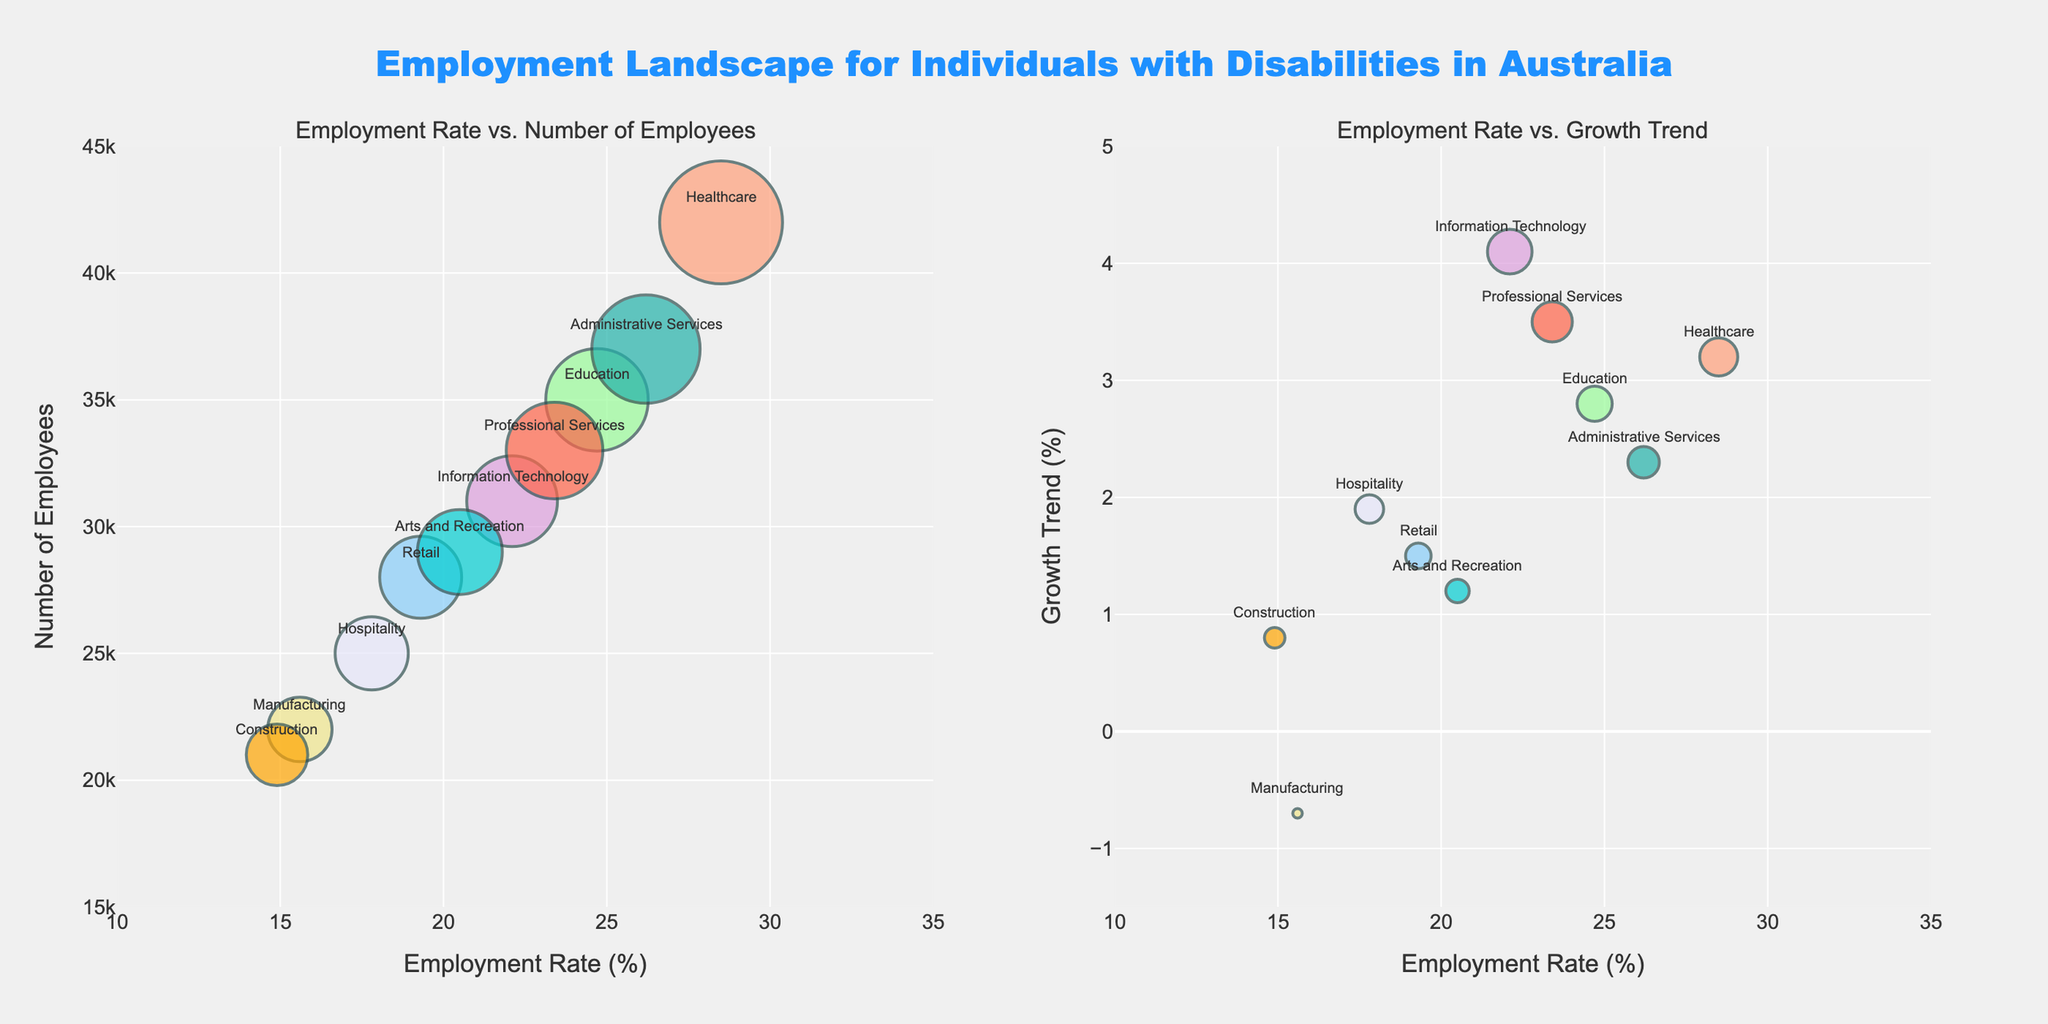What is the total number of employees in the Education and Healthcare industries combined? Looking at the figure, the number of employees in Education is 35,000 and in Healthcare is 42,000. Adding these together gives 35,000 + 42,000 = 77,000.
Answer: 77,000 Which industry has the highest employment rate? By observing the Employment Rate axis and the bubble positions, Healthcare has the highest employment rate at 28.5%.
Answer: Healthcare How does the growth trend of the Information Technology industry compare to that of Manufacturing? The Information Technology industry has a growth trend of 4.1%, while Manufacturing has a growth trend of -0.7%. Therefore, Information Technology is growing faster or Manufacturing is shrinking while IT is growing.
Answer: Information Technology is growing faster What is the employment rate for the industry with the smallest number of employees? The industry with the smallest number of employees is Construction with 21,000. The employment rate for Construction is 14.9%.
Answer: 14.9% Which industry appears to have the largest bubble in the "Employment Rate vs. Number of Employees" plot? In the first plot, the size of the bubbles corresponds to the number of employees. The largest bubble represents Healthcare, which has the highest number of employees at 42,000.
Answer: Healthcare Compare the employment rates of the Healthcare and Administrative Services industries. Healthcare has an employment rate of 28.5%, while Administrative Services has an employment rate of 26.2%. Therefore, Healthcare's rate is higher by 2.3 percentage points.
Answer: Healthcare's is higher Which industries show a negative growth trend? By looking at the Growth Trend axis and the bubble positions, Manufacturing shows a negative growth trend at -0.7%.
Answer: Manufacturing What is the average employment rate across all the industries listed? Adding up all the employment rates: 28.5 + 24.7 + 19.3 + 22.1 + 15.6 + 17.8 + 26.2 + 14.9 + 23.4 + 20.5 = 212. Adding these and dividing by the number of industries (10), the average is 212 / 10 = 21.2%.
Answer: 21.2% How does the number of employees in Retail compare to that in Professional Services? The number of employees in Retail is 28,000, while in Professional Services it is 33,000. Therefore, Professional Services has 5,000 more employees than Retail.
Answer: Professional Services has more Which industry has the highest growth trend and what is the value? By examining the Growth Trend axis and the positions of the bubbles, Information Technology has the highest growth trend at 4.1%.
Answer: Information Technology, 4.1% 